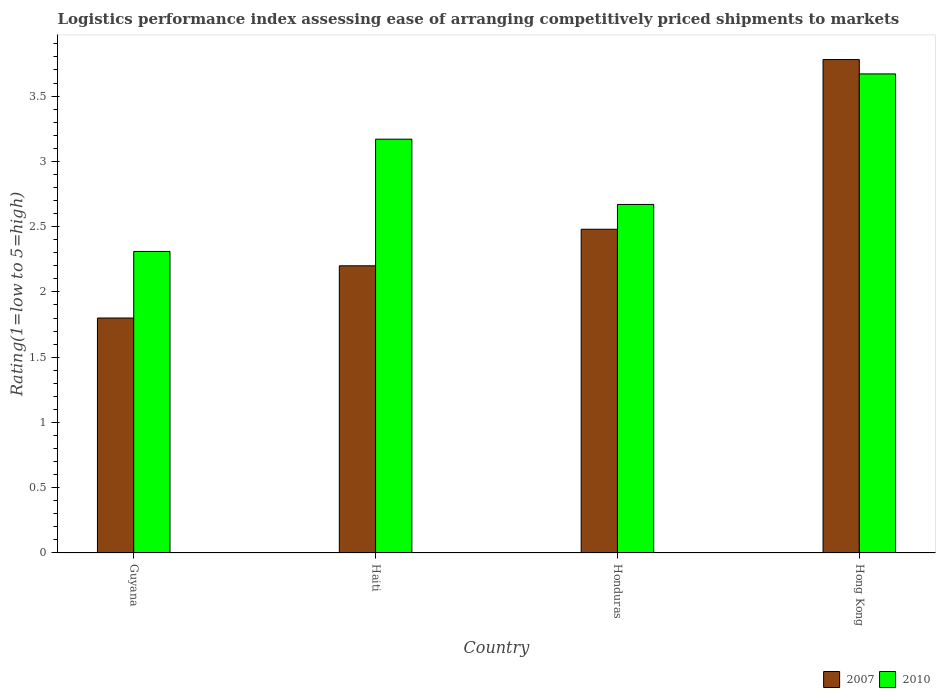How many different coloured bars are there?
Provide a short and direct response. 2. How many groups of bars are there?
Ensure brevity in your answer.  4. Are the number of bars on each tick of the X-axis equal?
Make the answer very short. Yes. What is the label of the 3rd group of bars from the left?
Offer a very short reply. Honduras. In how many cases, is the number of bars for a given country not equal to the number of legend labels?
Keep it short and to the point. 0. What is the Logistic performance index in 2007 in Haiti?
Give a very brief answer. 2.2. Across all countries, what is the maximum Logistic performance index in 2007?
Provide a short and direct response. 3.78. Across all countries, what is the minimum Logistic performance index in 2010?
Provide a succinct answer. 2.31. In which country was the Logistic performance index in 2007 maximum?
Offer a terse response. Hong Kong. In which country was the Logistic performance index in 2010 minimum?
Keep it short and to the point. Guyana. What is the total Logistic performance index in 2007 in the graph?
Keep it short and to the point. 10.26. What is the difference between the Logistic performance index in 2007 in Honduras and that in Hong Kong?
Ensure brevity in your answer.  -1.3. What is the difference between the Logistic performance index in 2007 in Guyana and the Logistic performance index in 2010 in Hong Kong?
Keep it short and to the point. -1.87. What is the average Logistic performance index in 2010 per country?
Offer a terse response. 2.96. What is the difference between the Logistic performance index of/in 2007 and Logistic performance index of/in 2010 in Honduras?
Provide a succinct answer. -0.19. What is the ratio of the Logistic performance index in 2007 in Haiti to that in Hong Kong?
Make the answer very short. 0.58. What is the difference between the highest and the second highest Logistic performance index in 2010?
Your response must be concise. 0.5. What is the difference between the highest and the lowest Logistic performance index in 2010?
Your answer should be compact. 1.36. In how many countries, is the Logistic performance index in 2010 greater than the average Logistic performance index in 2010 taken over all countries?
Provide a short and direct response. 2. How many bars are there?
Keep it short and to the point. 8. Are all the bars in the graph horizontal?
Keep it short and to the point. No. How many countries are there in the graph?
Provide a succinct answer. 4. Does the graph contain any zero values?
Offer a terse response. No. Where does the legend appear in the graph?
Ensure brevity in your answer.  Bottom right. How many legend labels are there?
Make the answer very short. 2. How are the legend labels stacked?
Your response must be concise. Horizontal. What is the title of the graph?
Your response must be concise. Logistics performance index assessing ease of arranging competitively priced shipments to markets. What is the label or title of the Y-axis?
Make the answer very short. Rating(1=low to 5=high). What is the Rating(1=low to 5=high) in 2010 in Guyana?
Your response must be concise. 2.31. What is the Rating(1=low to 5=high) of 2007 in Haiti?
Your response must be concise. 2.2. What is the Rating(1=low to 5=high) of 2010 in Haiti?
Your response must be concise. 3.17. What is the Rating(1=low to 5=high) in 2007 in Honduras?
Your answer should be very brief. 2.48. What is the Rating(1=low to 5=high) of 2010 in Honduras?
Make the answer very short. 2.67. What is the Rating(1=low to 5=high) of 2007 in Hong Kong?
Your answer should be very brief. 3.78. What is the Rating(1=low to 5=high) of 2010 in Hong Kong?
Your answer should be compact. 3.67. Across all countries, what is the maximum Rating(1=low to 5=high) of 2007?
Make the answer very short. 3.78. Across all countries, what is the maximum Rating(1=low to 5=high) of 2010?
Provide a short and direct response. 3.67. Across all countries, what is the minimum Rating(1=low to 5=high) in 2010?
Offer a very short reply. 2.31. What is the total Rating(1=low to 5=high) in 2007 in the graph?
Your answer should be very brief. 10.26. What is the total Rating(1=low to 5=high) of 2010 in the graph?
Make the answer very short. 11.82. What is the difference between the Rating(1=low to 5=high) in 2010 in Guyana and that in Haiti?
Make the answer very short. -0.86. What is the difference between the Rating(1=low to 5=high) of 2007 in Guyana and that in Honduras?
Give a very brief answer. -0.68. What is the difference between the Rating(1=low to 5=high) of 2010 in Guyana and that in Honduras?
Your answer should be compact. -0.36. What is the difference between the Rating(1=low to 5=high) of 2007 in Guyana and that in Hong Kong?
Give a very brief answer. -1.98. What is the difference between the Rating(1=low to 5=high) in 2010 in Guyana and that in Hong Kong?
Your answer should be compact. -1.36. What is the difference between the Rating(1=low to 5=high) in 2007 in Haiti and that in Honduras?
Offer a terse response. -0.28. What is the difference between the Rating(1=low to 5=high) in 2007 in Haiti and that in Hong Kong?
Give a very brief answer. -1.58. What is the difference between the Rating(1=low to 5=high) in 2010 in Haiti and that in Hong Kong?
Your response must be concise. -0.5. What is the difference between the Rating(1=low to 5=high) of 2007 in Honduras and that in Hong Kong?
Ensure brevity in your answer.  -1.3. What is the difference between the Rating(1=low to 5=high) in 2007 in Guyana and the Rating(1=low to 5=high) in 2010 in Haiti?
Make the answer very short. -1.37. What is the difference between the Rating(1=low to 5=high) in 2007 in Guyana and the Rating(1=low to 5=high) in 2010 in Honduras?
Your answer should be very brief. -0.87. What is the difference between the Rating(1=low to 5=high) of 2007 in Guyana and the Rating(1=low to 5=high) of 2010 in Hong Kong?
Offer a terse response. -1.87. What is the difference between the Rating(1=low to 5=high) of 2007 in Haiti and the Rating(1=low to 5=high) of 2010 in Honduras?
Your answer should be compact. -0.47. What is the difference between the Rating(1=low to 5=high) in 2007 in Haiti and the Rating(1=low to 5=high) in 2010 in Hong Kong?
Your answer should be very brief. -1.47. What is the difference between the Rating(1=low to 5=high) of 2007 in Honduras and the Rating(1=low to 5=high) of 2010 in Hong Kong?
Keep it short and to the point. -1.19. What is the average Rating(1=low to 5=high) in 2007 per country?
Your response must be concise. 2.56. What is the average Rating(1=low to 5=high) in 2010 per country?
Provide a short and direct response. 2.96. What is the difference between the Rating(1=low to 5=high) in 2007 and Rating(1=low to 5=high) in 2010 in Guyana?
Your answer should be compact. -0.51. What is the difference between the Rating(1=low to 5=high) in 2007 and Rating(1=low to 5=high) in 2010 in Haiti?
Offer a terse response. -0.97. What is the difference between the Rating(1=low to 5=high) of 2007 and Rating(1=low to 5=high) of 2010 in Honduras?
Ensure brevity in your answer.  -0.19. What is the difference between the Rating(1=low to 5=high) of 2007 and Rating(1=low to 5=high) of 2010 in Hong Kong?
Ensure brevity in your answer.  0.11. What is the ratio of the Rating(1=low to 5=high) of 2007 in Guyana to that in Haiti?
Offer a very short reply. 0.82. What is the ratio of the Rating(1=low to 5=high) in 2010 in Guyana to that in Haiti?
Your answer should be compact. 0.73. What is the ratio of the Rating(1=low to 5=high) in 2007 in Guyana to that in Honduras?
Offer a very short reply. 0.73. What is the ratio of the Rating(1=low to 5=high) in 2010 in Guyana to that in Honduras?
Your answer should be compact. 0.87. What is the ratio of the Rating(1=low to 5=high) in 2007 in Guyana to that in Hong Kong?
Your response must be concise. 0.48. What is the ratio of the Rating(1=low to 5=high) in 2010 in Guyana to that in Hong Kong?
Your response must be concise. 0.63. What is the ratio of the Rating(1=low to 5=high) of 2007 in Haiti to that in Honduras?
Ensure brevity in your answer.  0.89. What is the ratio of the Rating(1=low to 5=high) in 2010 in Haiti to that in Honduras?
Ensure brevity in your answer.  1.19. What is the ratio of the Rating(1=low to 5=high) in 2007 in Haiti to that in Hong Kong?
Offer a very short reply. 0.58. What is the ratio of the Rating(1=low to 5=high) of 2010 in Haiti to that in Hong Kong?
Your answer should be compact. 0.86. What is the ratio of the Rating(1=low to 5=high) in 2007 in Honduras to that in Hong Kong?
Give a very brief answer. 0.66. What is the ratio of the Rating(1=low to 5=high) of 2010 in Honduras to that in Hong Kong?
Provide a short and direct response. 0.73. What is the difference between the highest and the second highest Rating(1=low to 5=high) in 2007?
Offer a very short reply. 1.3. What is the difference between the highest and the lowest Rating(1=low to 5=high) in 2007?
Provide a succinct answer. 1.98. What is the difference between the highest and the lowest Rating(1=low to 5=high) of 2010?
Keep it short and to the point. 1.36. 